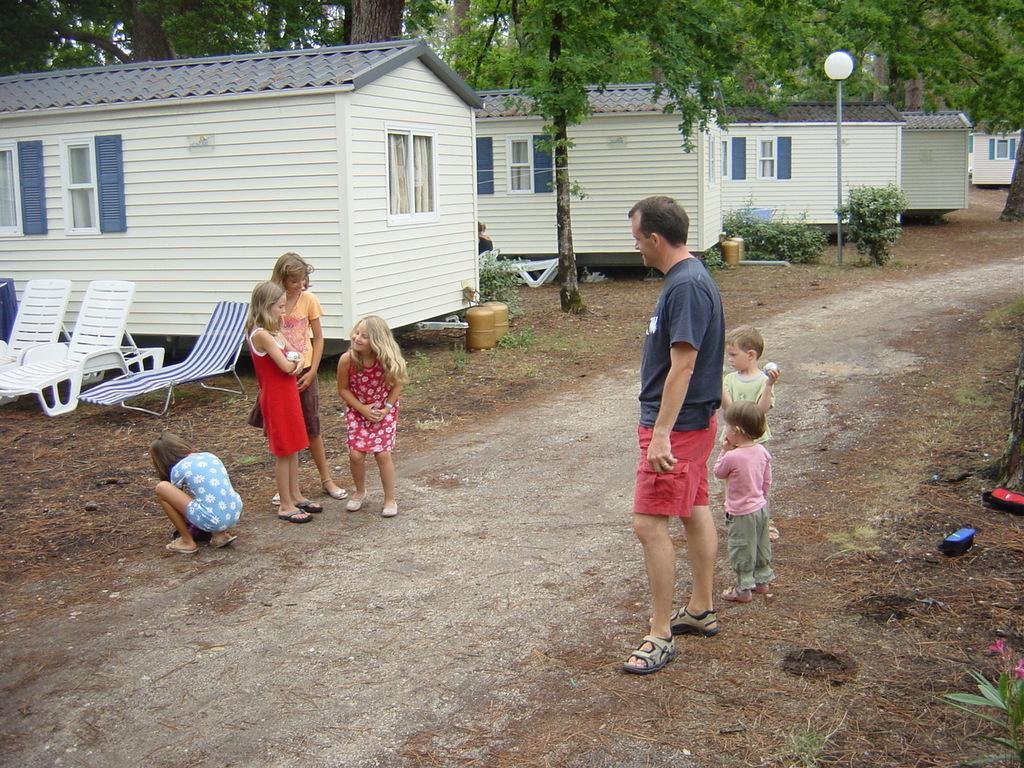Describe this image in one or two sentences. In this picture we can see persons on the road,in the background we can see sheds,trees and pole. 